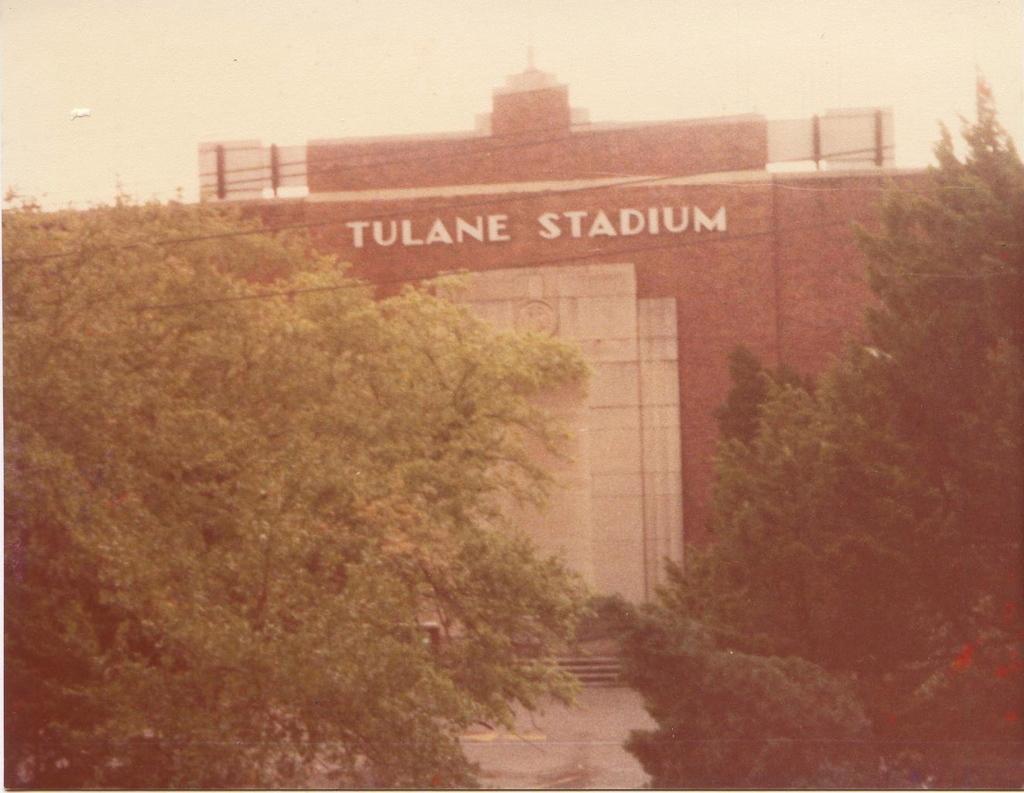In one or two sentences, can you explain what this image depicts? In this picture we can see a building named TULANE STADIUM. These are the trees. And there is a sky on the background. 